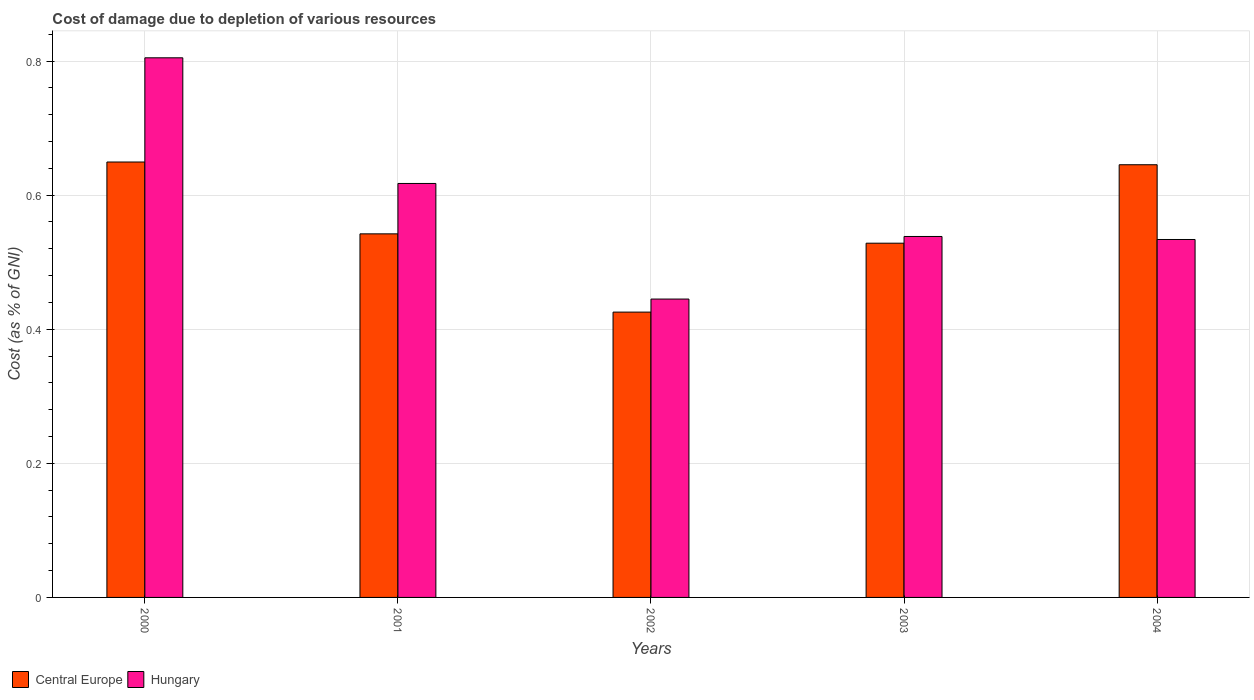How many different coloured bars are there?
Your answer should be very brief. 2. How many groups of bars are there?
Your answer should be compact. 5. Are the number of bars per tick equal to the number of legend labels?
Ensure brevity in your answer.  Yes. Are the number of bars on each tick of the X-axis equal?
Your answer should be very brief. Yes. How many bars are there on the 2nd tick from the left?
Provide a short and direct response. 2. What is the label of the 2nd group of bars from the left?
Provide a short and direct response. 2001. In how many cases, is the number of bars for a given year not equal to the number of legend labels?
Offer a very short reply. 0. What is the cost of damage caused due to the depletion of various resources in Hungary in 2000?
Make the answer very short. 0.8. Across all years, what is the maximum cost of damage caused due to the depletion of various resources in Central Europe?
Offer a terse response. 0.65. Across all years, what is the minimum cost of damage caused due to the depletion of various resources in Hungary?
Offer a very short reply. 0.45. In which year was the cost of damage caused due to the depletion of various resources in Hungary minimum?
Provide a short and direct response. 2002. What is the total cost of damage caused due to the depletion of various resources in Central Europe in the graph?
Offer a terse response. 2.79. What is the difference between the cost of damage caused due to the depletion of various resources in Central Europe in 2001 and that in 2004?
Keep it short and to the point. -0.1. What is the difference between the cost of damage caused due to the depletion of various resources in Hungary in 2003 and the cost of damage caused due to the depletion of various resources in Central Europe in 2004?
Keep it short and to the point. -0.11. What is the average cost of damage caused due to the depletion of various resources in Hungary per year?
Make the answer very short. 0.59. In the year 2000, what is the difference between the cost of damage caused due to the depletion of various resources in Central Europe and cost of damage caused due to the depletion of various resources in Hungary?
Ensure brevity in your answer.  -0.16. What is the ratio of the cost of damage caused due to the depletion of various resources in Central Europe in 2000 to that in 2004?
Keep it short and to the point. 1.01. Is the cost of damage caused due to the depletion of various resources in Hungary in 2001 less than that in 2003?
Offer a very short reply. No. Is the difference between the cost of damage caused due to the depletion of various resources in Central Europe in 2002 and 2003 greater than the difference between the cost of damage caused due to the depletion of various resources in Hungary in 2002 and 2003?
Ensure brevity in your answer.  No. What is the difference between the highest and the second highest cost of damage caused due to the depletion of various resources in Central Europe?
Make the answer very short. 0. What is the difference between the highest and the lowest cost of damage caused due to the depletion of various resources in Central Europe?
Ensure brevity in your answer.  0.22. In how many years, is the cost of damage caused due to the depletion of various resources in Central Europe greater than the average cost of damage caused due to the depletion of various resources in Central Europe taken over all years?
Your response must be concise. 2. What does the 1st bar from the left in 2002 represents?
Keep it short and to the point. Central Europe. What does the 1st bar from the right in 2003 represents?
Offer a terse response. Hungary. How many bars are there?
Your answer should be very brief. 10. Are all the bars in the graph horizontal?
Provide a succinct answer. No. How many years are there in the graph?
Your answer should be very brief. 5. Are the values on the major ticks of Y-axis written in scientific E-notation?
Your answer should be compact. No. Does the graph contain any zero values?
Ensure brevity in your answer.  No. Where does the legend appear in the graph?
Your response must be concise. Bottom left. What is the title of the graph?
Provide a succinct answer. Cost of damage due to depletion of various resources. What is the label or title of the X-axis?
Ensure brevity in your answer.  Years. What is the label or title of the Y-axis?
Make the answer very short. Cost (as % of GNI). What is the Cost (as % of GNI) of Central Europe in 2000?
Keep it short and to the point. 0.65. What is the Cost (as % of GNI) in Hungary in 2000?
Ensure brevity in your answer.  0.8. What is the Cost (as % of GNI) in Central Europe in 2001?
Ensure brevity in your answer.  0.54. What is the Cost (as % of GNI) in Hungary in 2001?
Provide a succinct answer. 0.62. What is the Cost (as % of GNI) in Central Europe in 2002?
Make the answer very short. 0.43. What is the Cost (as % of GNI) in Hungary in 2002?
Provide a succinct answer. 0.45. What is the Cost (as % of GNI) of Central Europe in 2003?
Your answer should be compact. 0.53. What is the Cost (as % of GNI) of Hungary in 2003?
Your answer should be very brief. 0.54. What is the Cost (as % of GNI) of Central Europe in 2004?
Keep it short and to the point. 0.65. What is the Cost (as % of GNI) of Hungary in 2004?
Your answer should be compact. 0.53. Across all years, what is the maximum Cost (as % of GNI) of Central Europe?
Ensure brevity in your answer.  0.65. Across all years, what is the maximum Cost (as % of GNI) in Hungary?
Ensure brevity in your answer.  0.8. Across all years, what is the minimum Cost (as % of GNI) of Central Europe?
Ensure brevity in your answer.  0.43. Across all years, what is the minimum Cost (as % of GNI) of Hungary?
Your answer should be compact. 0.45. What is the total Cost (as % of GNI) in Central Europe in the graph?
Provide a succinct answer. 2.79. What is the total Cost (as % of GNI) in Hungary in the graph?
Offer a very short reply. 2.94. What is the difference between the Cost (as % of GNI) in Central Europe in 2000 and that in 2001?
Keep it short and to the point. 0.11. What is the difference between the Cost (as % of GNI) of Hungary in 2000 and that in 2001?
Your answer should be compact. 0.19. What is the difference between the Cost (as % of GNI) of Central Europe in 2000 and that in 2002?
Offer a terse response. 0.22. What is the difference between the Cost (as % of GNI) in Hungary in 2000 and that in 2002?
Ensure brevity in your answer.  0.36. What is the difference between the Cost (as % of GNI) in Central Europe in 2000 and that in 2003?
Your answer should be compact. 0.12. What is the difference between the Cost (as % of GNI) of Hungary in 2000 and that in 2003?
Offer a very short reply. 0.27. What is the difference between the Cost (as % of GNI) in Central Europe in 2000 and that in 2004?
Your answer should be very brief. 0. What is the difference between the Cost (as % of GNI) of Hungary in 2000 and that in 2004?
Provide a succinct answer. 0.27. What is the difference between the Cost (as % of GNI) in Central Europe in 2001 and that in 2002?
Keep it short and to the point. 0.12. What is the difference between the Cost (as % of GNI) of Hungary in 2001 and that in 2002?
Keep it short and to the point. 0.17. What is the difference between the Cost (as % of GNI) in Central Europe in 2001 and that in 2003?
Ensure brevity in your answer.  0.01. What is the difference between the Cost (as % of GNI) of Hungary in 2001 and that in 2003?
Ensure brevity in your answer.  0.08. What is the difference between the Cost (as % of GNI) of Central Europe in 2001 and that in 2004?
Provide a succinct answer. -0.1. What is the difference between the Cost (as % of GNI) in Hungary in 2001 and that in 2004?
Your answer should be very brief. 0.08. What is the difference between the Cost (as % of GNI) in Central Europe in 2002 and that in 2003?
Offer a very short reply. -0.1. What is the difference between the Cost (as % of GNI) in Hungary in 2002 and that in 2003?
Provide a succinct answer. -0.09. What is the difference between the Cost (as % of GNI) of Central Europe in 2002 and that in 2004?
Keep it short and to the point. -0.22. What is the difference between the Cost (as % of GNI) in Hungary in 2002 and that in 2004?
Your answer should be compact. -0.09. What is the difference between the Cost (as % of GNI) of Central Europe in 2003 and that in 2004?
Your response must be concise. -0.12. What is the difference between the Cost (as % of GNI) in Hungary in 2003 and that in 2004?
Keep it short and to the point. 0. What is the difference between the Cost (as % of GNI) in Central Europe in 2000 and the Cost (as % of GNI) in Hungary in 2001?
Your answer should be compact. 0.03. What is the difference between the Cost (as % of GNI) in Central Europe in 2000 and the Cost (as % of GNI) in Hungary in 2002?
Your answer should be compact. 0.2. What is the difference between the Cost (as % of GNI) of Central Europe in 2000 and the Cost (as % of GNI) of Hungary in 2003?
Your answer should be compact. 0.11. What is the difference between the Cost (as % of GNI) of Central Europe in 2000 and the Cost (as % of GNI) of Hungary in 2004?
Provide a succinct answer. 0.12. What is the difference between the Cost (as % of GNI) in Central Europe in 2001 and the Cost (as % of GNI) in Hungary in 2002?
Your answer should be very brief. 0.1. What is the difference between the Cost (as % of GNI) in Central Europe in 2001 and the Cost (as % of GNI) in Hungary in 2003?
Ensure brevity in your answer.  0. What is the difference between the Cost (as % of GNI) of Central Europe in 2001 and the Cost (as % of GNI) of Hungary in 2004?
Ensure brevity in your answer.  0.01. What is the difference between the Cost (as % of GNI) of Central Europe in 2002 and the Cost (as % of GNI) of Hungary in 2003?
Your response must be concise. -0.11. What is the difference between the Cost (as % of GNI) in Central Europe in 2002 and the Cost (as % of GNI) in Hungary in 2004?
Your answer should be very brief. -0.11. What is the difference between the Cost (as % of GNI) of Central Europe in 2003 and the Cost (as % of GNI) of Hungary in 2004?
Your answer should be compact. -0.01. What is the average Cost (as % of GNI) of Central Europe per year?
Your response must be concise. 0.56. What is the average Cost (as % of GNI) in Hungary per year?
Offer a very short reply. 0.59. In the year 2000, what is the difference between the Cost (as % of GNI) of Central Europe and Cost (as % of GNI) of Hungary?
Your answer should be very brief. -0.16. In the year 2001, what is the difference between the Cost (as % of GNI) in Central Europe and Cost (as % of GNI) in Hungary?
Offer a terse response. -0.08. In the year 2002, what is the difference between the Cost (as % of GNI) of Central Europe and Cost (as % of GNI) of Hungary?
Give a very brief answer. -0.02. In the year 2003, what is the difference between the Cost (as % of GNI) in Central Europe and Cost (as % of GNI) in Hungary?
Make the answer very short. -0.01. In the year 2004, what is the difference between the Cost (as % of GNI) in Central Europe and Cost (as % of GNI) in Hungary?
Your answer should be compact. 0.11. What is the ratio of the Cost (as % of GNI) of Central Europe in 2000 to that in 2001?
Offer a terse response. 1.2. What is the ratio of the Cost (as % of GNI) in Hungary in 2000 to that in 2001?
Ensure brevity in your answer.  1.3. What is the ratio of the Cost (as % of GNI) in Central Europe in 2000 to that in 2002?
Provide a short and direct response. 1.53. What is the ratio of the Cost (as % of GNI) in Hungary in 2000 to that in 2002?
Ensure brevity in your answer.  1.81. What is the ratio of the Cost (as % of GNI) of Central Europe in 2000 to that in 2003?
Your response must be concise. 1.23. What is the ratio of the Cost (as % of GNI) of Hungary in 2000 to that in 2003?
Your answer should be very brief. 1.5. What is the ratio of the Cost (as % of GNI) in Central Europe in 2000 to that in 2004?
Make the answer very short. 1.01. What is the ratio of the Cost (as % of GNI) in Hungary in 2000 to that in 2004?
Offer a very short reply. 1.51. What is the ratio of the Cost (as % of GNI) of Central Europe in 2001 to that in 2002?
Offer a very short reply. 1.27. What is the ratio of the Cost (as % of GNI) of Hungary in 2001 to that in 2002?
Make the answer very short. 1.39. What is the ratio of the Cost (as % of GNI) in Central Europe in 2001 to that in 2003?
Give a very brief answer. 1.03. What is the ratio of the Cost (as % of GNI) in Hungary in 2001 to that in 2003?
Ensure brevity in your answer.  1.15. What is the ratio of the Cost (as % of GNI) in Central Europe in 2001 to that in 2004?
Ensure brevity in your answer.  0.84. What is the ratio of the Cost (as % of GNI) of Hungary in 2001 to that in 2004?
Provide a succinct answer. 1.16. What is the ratio of the Cost (as % of GNI) in Central Europe in 2002 to that in 2003?
Give a very brief answer. 0.81. What is the ratio of the Cost (as % of GNI) in Hungary in 2002 to that in 2003?
Offer a very short reply. 0.83. What is the ratio of the Cost (as % of GNI) in Central Europe in 2002 to that in 2004?
Make the answer very short. 0.66. What is the ratio of the Cost (as % of GNI) of Hungary in 2002 to that in 2004?
Give a very brief answer. 0.83. What is the ratio of the Cost (as % of GNI) of Central Europe in 2003 to that in 2004?
Your answer should be compact. 0.82. What is the ratio of the Cost (as % of GNI) in Hungary in 2003 to that in 2004?
Your answer should be very brief. 1.01. What is the difference between the highest and the second highest Cost (as % of GNI) in Central Europe?
Make the answer very short. 0. What is the difference between the highest and the second highest Cost (as % of GNI) in Hungary?
Your response must be concise. 0.19. What is the difference between the highest and the lowest Cost (as % of GNI) of Central Europe?
Your answer should be compact. 0.22. What is the difference between the highest and the lowest Cost (as % of GNI) in Hungary?
Give a very brief answer. 0.36. 